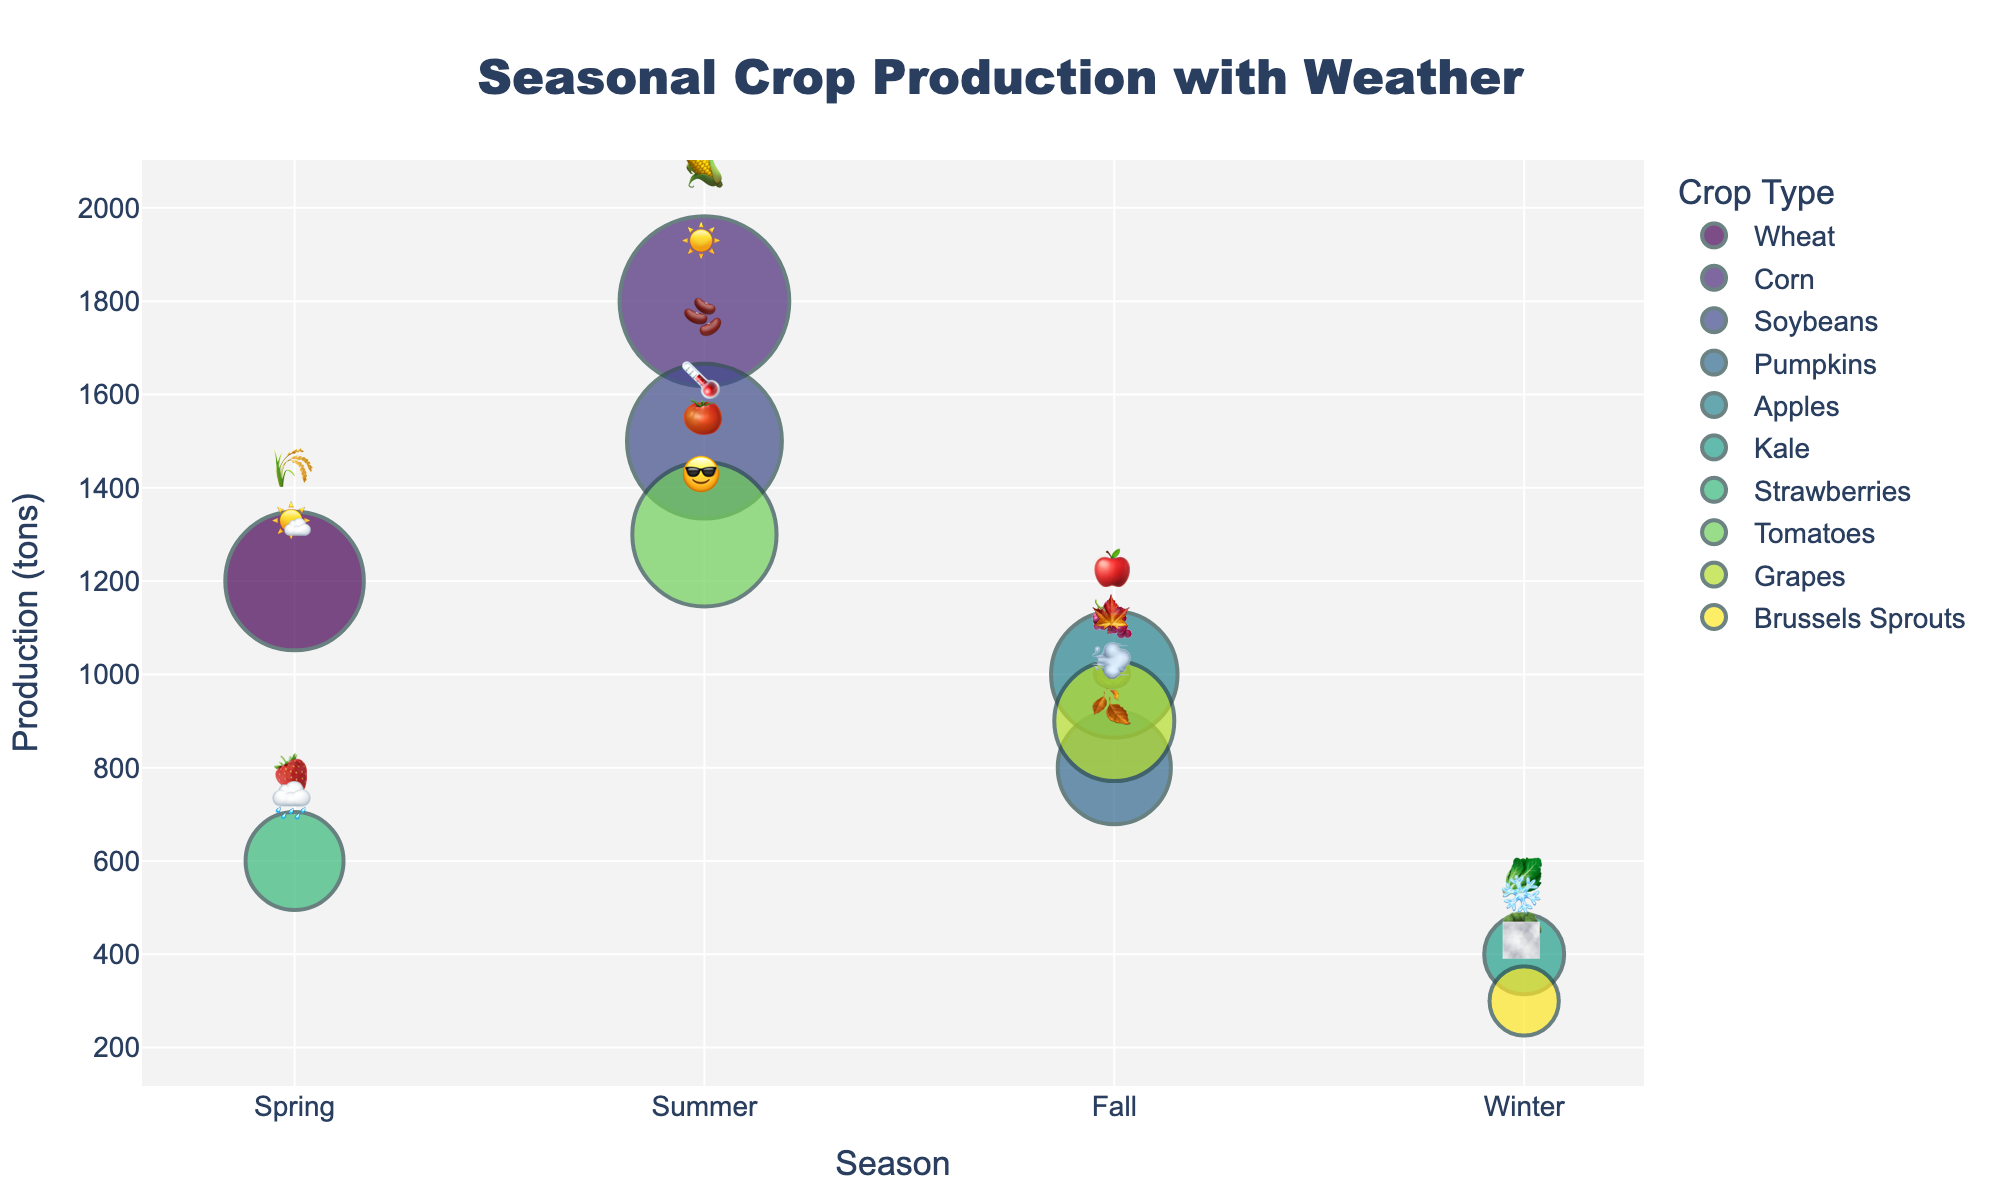What is the title of the figure? The title is positioned at the top-center of the figure, clearly indicating the main focus of the plot.
Answer: Seasonal Crop Production with Weather Which crop has the highest production in summer? By examining the production values for each crop in summer, compare 1800 tons for Corn, 1500 tons for Soybeans, and 1300 tons for Tomatoes. Corn has the highest production.
Answer: Corn How does the production of kale in winter compare to the production of brussels sprouts in winter? In winter, Kale has a production of 400 tons while Brussels Sprouts have a production of 300 tons. Kale's production is higher.
Answer: Kale's production is higher Which season has the lowest overall crop production? Sum the production values for each season and identify the one with the smallest sum. Spring: 1800, Summer: 4600, Fall: 2700, Winter: 700. Winter has the lowest overall production.
Answer: Winter What weather emoji is associated with tomato production? Look at the entry for tomatoes, which also indicates the corresponding weather emoji.
Answer: 😎 What is the total production of crops in fall? Sum the production values of Pumpkins (800), Apples (1000), and Grapes (900) for fall. 800 + 1000 + 900 = 2700 tons.
Answer: 2700 tons What type of weather is associated with the highest crop production? Compare the weather conditions for all the highest production values. For Corn production at 1800 tons in summer, the weather was Hot.
Answer: Hot Which crop has the lowest production and what season is it produced in? Identify the crop with the lowest production value, which is Brussels Sprouts with 300 tons, produced in winter.
Answer: Brussels Sprouts, Winter How does the production of strawberries in spring compare to apples in fall? Compare the production numbers: Strawberries (600 tons) in Spring vs. Apples (1000 tons) in Fall. Apples have higher production.
Answer: Apples have higher production Which crop emoji represents the crop produced in rainy weather during spring? Identify the crop and corresponding emoji for spring with rainy weather.
Answer: 🍓 